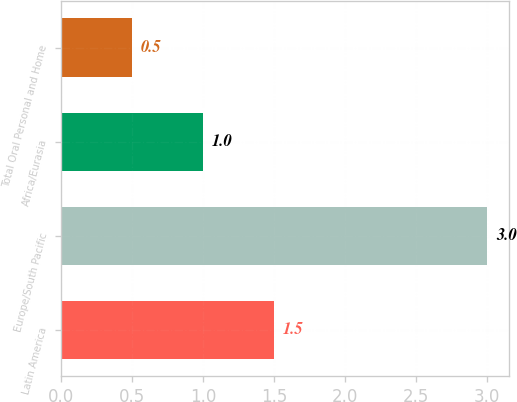Convert chart to OTSL. <chart><loc_0><loc_0><loc_500><loc_500><bar_chart><fcel>Latin America<fcel>Europe/South Pacific<fcel>Africa/Eurasia<fcel>Total Oral Personal and Home<nl><fcel>1.5<fcel>3<fcel>1<fcel>0.5<nl></chart> 